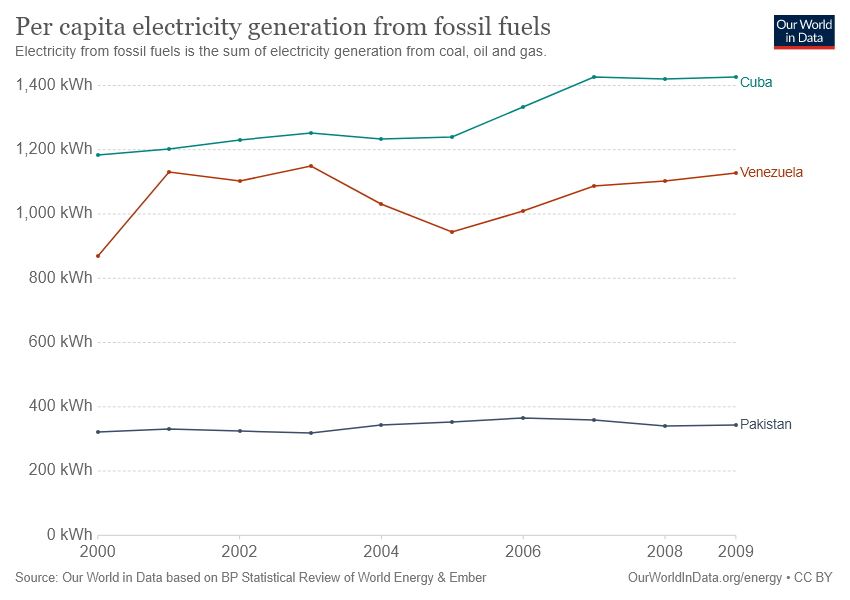Highlight a few significant elements in this photo. Venezuela is represented by the red color line. The number of countries that generated more than 800 kWh per capita of electricity generation over the years is 2. 